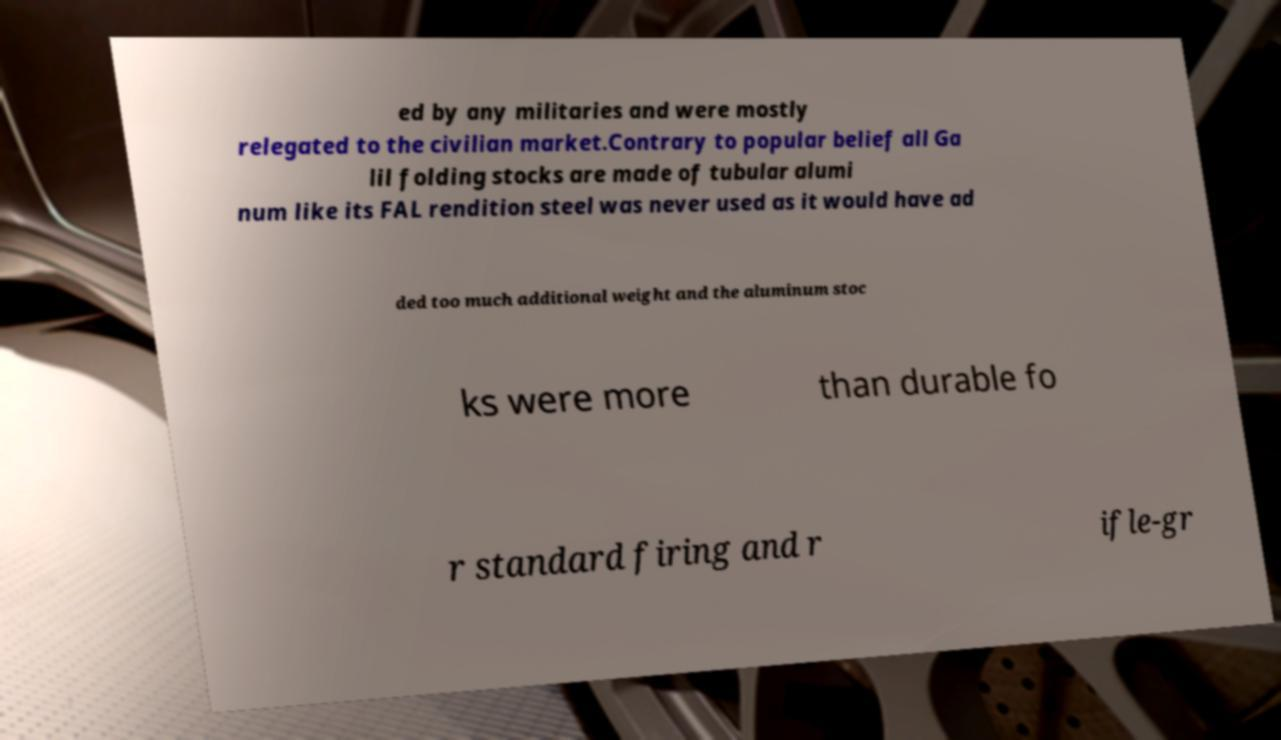Can you read and provide the text displayed in the image?This photo seems to have some interesting text. Can you extract and type it out for me? ed by any militaries and were mostly relegated to the civilian market.Contrary to popular belief all Ga lil folding stocks are made of tubular alumi num like its FAL rendition steel was never used as it would have ad ded too much additional weight and the aluminum stoc ks were more than durable fo r standard firing and r ifle-gr 